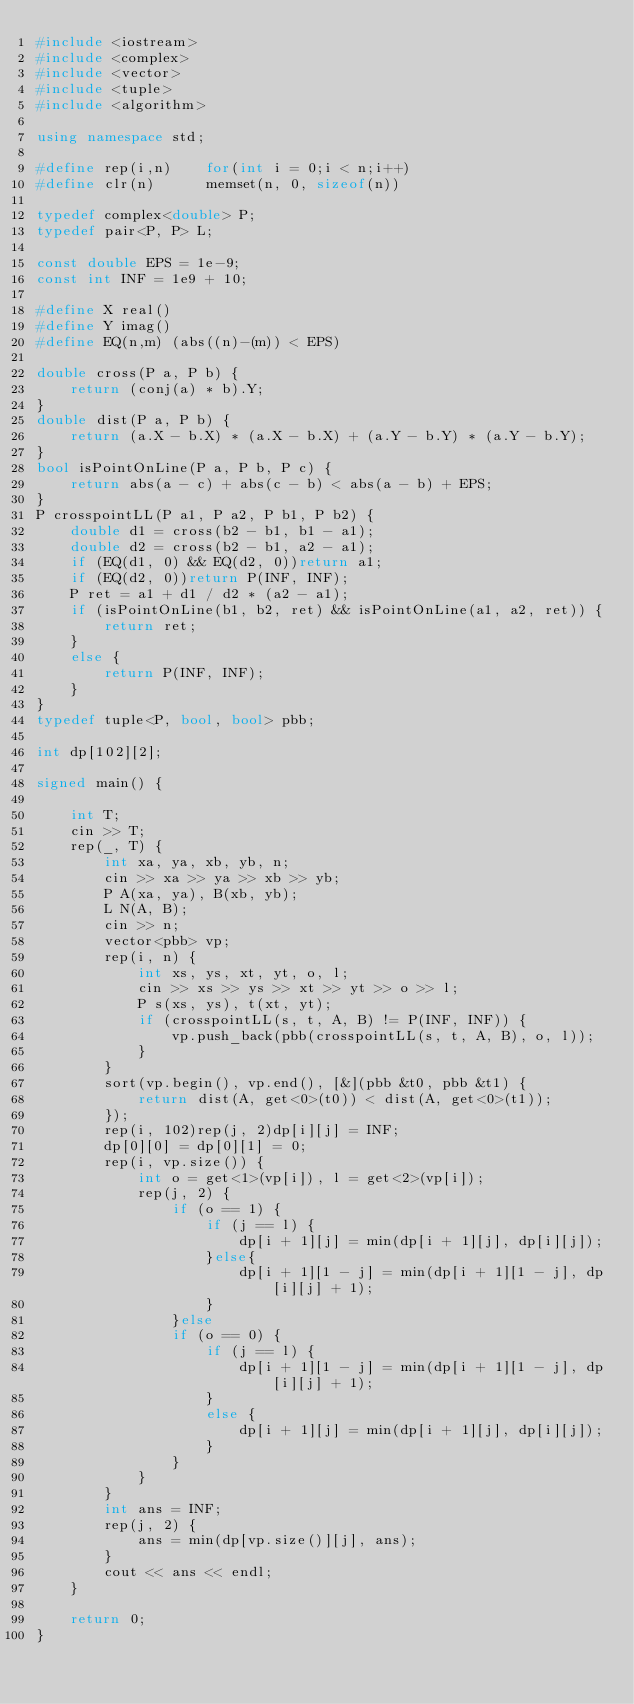<code> <loc_0><loc_0><loc_500><loc_500><_C++_>#include <iostream>
#include <complex>
#include <vector>
#include <tuple>
#include <algorithm>

using namespace std;

#define rep(i,n)	for(int i = 0;i < n;i++)
#define clr(n)		memset(n, 0, sizeof(n))

typedef complex<double> P;
typedef pair<P, P> L;

const double EPS = 1e-9;
const int INF = 1e9 + 10;

#define X real()
#define Y imag()
#define EQ(n,m) (abs((n)-(m)) < EPS)

double cross(P a, P b) {
	return (conj(a) * b).Y;
}
double dist(P a, P b) {
	return (a.X - b.X) * (a.X - b.X) + (a.Y - b.Y) * (a.Y - b.Y);
}
bool isPointOnLine(P a, P b, P c) {
	return abs(a - c) + abs(c - b) < abs(a - b) + EPS;
}
P crosspointLL(P a1, P a2, P b1, P b2) {
	double d1 = cross(b2 - b1, b1 - a1);
	double d2 = cross(b2 - b1, a2 - a1);
	if (EQ(d1, 0) && EQ(d2, 0))return a1;
	if (EQ(d2, 0))return P(INF, INF);
	P ret = a1 + d1 / d2 * (a2 - a1);
	if (isPointOnLine(b1, b2, ret) && isPointOnLine(a1, a2, ret)) {
		return ret;
	}
	else {
		return P(INF, INF);
	}
}
typedef tuple<P, bool, bool> pbb;

int dp[102][2];

signed main() {

	int T;
	cin >> T;
	rep(_, T) {
		int xa, ya, xb, yb, n;
		cin >> xa >> ya >> xb >> yb;
		P A(xa, ya), B(xb, yb);
		L N(A, B);
		cin >> n;
		vector<pbb> vp;
		rep(i, n) {
			int xs, ys, xt, yt, o, l;
			cin >> xs >> ys >> xt >> yt >> o >> l;
			P s(xs, ys), t(xt, yt);
			if (crosspointLL(s, t, A, B) != P(INF, INF)) {
				vp.push_back(pbb(crosspointLL(s, t, A, B), o, l));
			}
		}
		sort(vp.begin(), vp.end(), [&](pbb &t0, pbb &t1) {
			return dist(A, get<0>(t0)) < dist(A, get<0>(t1));
		});
		rep(i, 102)rep(j, 2)dp[i][j] = INF;
		dp[0][0] = dp[0][1] = 0;
		rep(i, vp.size()) {
			int o = get<1>(vp[i]), l = get<2>(vp[i]);
			rep(j, 2) {
				if (o == 1) {
					if (j == l) {
						dp[i + 1][j] = min(dp[i + 1][j], dp[i][j]);
					}else{
						dp[i + 1][1 - j] = min(dp[i + 1][1 - j], dp[i][j] + 1);
					}
				}else
				if (o == 0) {
					if (j == l) {
						dp[i + 1][1 - j] = min(dp[i + 1][1 - j], dp[i][j] + 1);
					}
					else {
						dp[i + 1][j] = min(dp[i + 1][j], dp[i][j]);
					}
				}
			}
		}
		int ans = INF;
		rep(j, 2) {
			ans = min(dp[vp.size()][j], ans);
		}
		cout << ans << endl;
	}

	return 0;
}</code> 